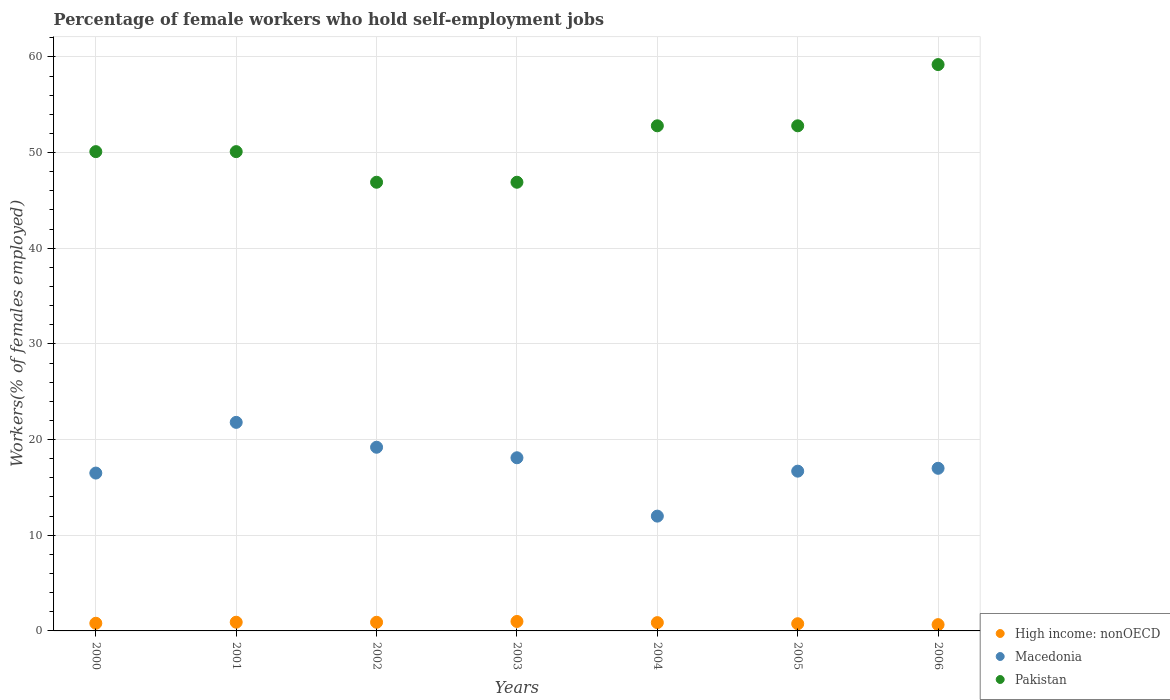How many different coloured dotlines are there?
Keep it short and to the point. 3. Is the number of dotlines equal to the number of legend labels?
Offer a very short reply. Yes. What is the percentage of self-employed female workers in High income: nonOECD in 2002?
Provide a succinct answer. 0.9. Across all years, what is the maximum percentage of self-employed female workers in Macedonia?
Your response must be concise. 21.8. Across all years, what is the minimum percentage of self-employed female workers in Pakistan?
Keep it short and to the point. 46.9. In which year was the percentage of self-employed female workers in Macedonia maximum?
Offer a very short reply. 2001. What is the total percentage of self-employed female workers in Macedonia in the graph?
Offer a terse response. 121.3. What is the difference between the percentage of self-employed female workers in Macedonia in 2005 and that in 2006?
Provide a succinct answer. -0.3. What is the difference between the percentage of self-employed female workers in Pakistan in 2003 and the percentage of self-employed female workers in Macedonia in 2001?
Your answer should be very brief. 25.1. What is the average percentage of self-employed female workers in High income: nonOECD per year?
Offer a very short reply. 0.84. In the year 2002, what is the difference between the percentage of self-employed female workers in Macedonia and percentage of self-employed female workers in Pakistan?
Give a very brief answer. -27.7. What is the ratio of the percentage of self-employed female workers in Pakistan in 2003 to that in 2006?
Provide a succinct answer. 0.79. Is the percentage of self-employed female workers in High income: nonOECD in 2001 less than that in 2003?
Provide a succinct answer. Yes. What is the difference between the highest and the second highest percentage of self-employed female workers in Pakistan?
Provide a short and direct response. 6.4. What is the difference between the highest and the lowest percentage of self-employed female workers in Pakistan?
Provide a short and direct response. 12.3. Does the percentage of self-employed female workers in Pakistan monotonically increase over the years?
Offer a very short reply. No. Is the percentage of self-employed female workers in Macedonia strictly less than the percentage of self-employed female workers in High income: nonOECD over the years?
Offer a terse response. No. How many legend labels are there?
Offer a terse response. 3. What is the title of the graph?
Keep it short and to the point. Percentage of female workers who hold self-employment jobs. Does "Italy" appear as one of the legend labels in the graph?
Provide a succinct answer. No. What is the label or title of the X-axis?
Offer a very short reply. Years. What is the label or title of the Y-axis?
Provide a succinct answer. Workers(% of females employed). What is the Workers(% of females employed) of High income: nonOECD in 2000?
Make the answer very short. 0.8. What is the Workers(% of females employed) in Pakistan in 2000?
Provide a succinct answer. 50.1. What is the Workers(% of females employed) in High income: nonOECD in 2001?
Give a very brief answer. 0.91. What is the Workers(% of females employed) in Macedonia in 2001?
Keep it short and to the point. 21.8. What is the Workers(% of females employed) of Pakistan in 2001?
Give a very brief answer. 50.1. What is the Workers(% of females employed) of High income: nonOECD in 2002?
Your answer should be compact. 0.9. What is the Workers(% of females employed) of Macedonia in 2002?
Your answer should be compact. 19.2. What is the Workers(% of females employed) of Pakistan in 2002?
Your answer should be very brief. 46.9. What is the Workers(% of females employed) of High income: nonOECD in 2003?
Your response must be concise. 0.99. What is the Workers(% of females employed) of Macedonia in 2003?
Your response must be concise. 18.1. What is the Workers(% of females employed) of Pakistan in 2003?
Provide a short and direct response. 46.9. What is the Workers(% of females employed) in High income: nonOECD in 2004?
Provide a succinct answer. 0.87. What is the Workers(% of females employed) of Pakistan in 2004?
Give a very brief answer. 52.8. What is the Workers(% of females employed) of High income: nonOECD in 2005?
Provide a succinct answer. 0.75. What is the Workers(% of females employed) in Macedonia in 2005?
Provide a succinct answer. 16.7. What is the Workers(% of females employed) of Pakistan in 2005?
Offer a very short reply. 52.8. What is the Workers(% of females employed) of High income: nonOECD in 2006?
Keep it short and to the point. 0.66. What is the Workers(% of females employed) in Macedonia in 2006?
Give a very brief answer. 17. What is the Workers(% of females employed) of Pakistan in 2006?
Keep it short and to the point. 59.2. Across all years, what is the maximum Workers(% of females employed) in High income: nonOECD?
Your response must be concise. 0.99. Across all years, what is the maximum Workers(% of females employed) in Macedonia?
Make the answer very short. 21.8. Across all years, what is the maximum Workers(% of females employed) of Pakistan?
Ensure brevity in your answer.  59.2. Across all years, what is the minimum Workers(% of females employed) in High income: nonOECD?
Provide a succinct answer. 0.66. Across all years, what is the minimum Workers(% of females employed) of Macedonia?
Offer a very short reply. 12. Across all years, what is the minimum Workers(% of females employed) of Pakistan?
Provide a short and direct response. 46.9. What is the total Workers(% of females employed) in High income: nonOECD in the graph?
Provide a succinct answer. 5.88. What is the total Workers(% of females employed) of Macedonia in the graph?
Your answer should be compact. 121.3. What is the total Workers(% of females employed) in Pakistan in the graph?
Keep it short and to the point. 358.8. What is the difference between the Workers(% of females employed) in High income: nonOECD in 2000 and that in 2001?
Your response must be concise. -0.11. What is the difference between the Workers(% of females employed) of Macedonia in 2000 and that in 2001?
Keep it short and to the point. -5.3. What is the difference between the Workers(% of females employed) of High income: nonOECD in 2000 and that in 2002?
Make the answer very short. -0.1. What is the difference between the Workers(% of females employed) in Pakistan in 2000 and that in 2002?
Your response must be concise. 3.2. What is the difference between the Workers(% of females employed) of High income: nonOECD in 2000 and that in 2003?
Give a very brief answer. -0.19. What is the difference between the Workers(% of females employed) of High income: nonOECD in 2000 and that in 2004?
Your answer should be compact. -0.07. What is the difference between the Workers(% of females employed) in Pakistan in 2000 and that in 2004?
Your response must be concise. -2.7. What is the difference between the Workers(% of females employed) in High income: nonOECD in 2000 and that in 2005?
Ensure brevity in your answer.  0.05. What is the difference between the Workers(% of females employed) in Pakistan in 2000 and that in 2005?
Offer a terse response. -2.7. What is the difference between the Workers(% of females employed) in High income: nonOECD in 2000 and that in 2006?
Keep it short and to the point. 0.14. What is the difference between the Workers(% of females employed) in High income: nonOECD in 2001 and that in 2002?
Your response must be concise. 0.01. What is the difference between the Workers(% of females employed) in High income: nonOECD in 2001 and that in 2003?
Your answer should be very brief. -0.08. What is the difference between the Workers(% of females employed) in Pakistan in 2001 and that in 2003?
Give a very brief answer. 3.2. What is the difference between the Workers(% of females employed) in High income: nonOECD in 2001 and that in 2004?
Make the answer very short. 0.04. What is the difference between the Workers(% of females employed) of Macedonia in 2001 and that in 2004?
Ensure brevity in your answer.  9.8. What is the difference between the Workers(% of females employed) in Pakistan in 2001 and that in 2004?
Offer a terse response. -2.7. What is the difference between the Workers(% of females employed) in High income: nonOECD in 2001 and that in 2005?
Your answer should be very brief. 0.16. What is the difference between the Workers(% of females employed) of Macedonia in 2001 and that in 2005?
Make the answer very short. 5.1. What is the difference between the Workers(% of females employed) in High income: nonOECD in 2001 and that in 2006?
Your response must be concise. 0.25. What is the difference between the Workers(% of females employed) of Macedonia in 2001 and that in 2006?
Your response must be concise. 4.8. What is the difference between the Workers(% of females employed) in Pakistan in 2001 and that in 2006?
Keep it short and to the point. -9.1. What is the difference between the Workers(% of females employed) of High income: nonOECD in 2002 and that in 2003?
Make the answer very short. -0.08. What is the difference between the Workers(% of females employed) of Macedonia in 2002 and that in 2003?
Keep it short and to the point. 1.1. What is the difference between the Workers(% of females employed) of Pakistan in 2002 and that in 2003?
Offer a terse response. 0. What is the difference between the Workers(% of females employed) in High income: nonOECD in 2002 and that in 2004?
Offer a very short reply. 0.04. What is the difference between the Workers(% of females employed) of Pakistan in 2002 and that in 2004?
Provide a short and direct response. -5.9. What is the difference between the Workers(% of females employed) of High income: nonOECD in 2002 and that in 2005?
Your answer should be very brief. 0.15. What is the difference between the Workers(% of females employed) of Pakistan in 2002 and that in 2005?
Your answer should be compact. -5.9. What is the difference between the Workers(% of females employed) in High income: nonOECD in 2002 and that in 2006?
Your answer should be very brief. 0.25. What is the difference between the Workers(% of females employed) of Pakistan in 2002 and that in 2006?
Give a very brief answer. -12.3. What is the difference between the Workers(% of females employed) of High income: nonOECD in 2003 and that in 2004?
Ensure brevity in your answer.  0.12. What is the difference between the Workers(% of females employed) of Pakistan in 2003 and that in 2004?
Keep it short and to the point. -5.9. What is the difference between the Workers(% of females employed) of High income: nonOECD in 2003 and that in 2005?
Your response must be concise. 0.24. What is the difference between the Workers(% of females employed) of Pakistan in 2003 and that in 2005?
Make the answer very short. -5.9. What is the difference between the Workers(% of females employed) in High income: nonOECD in 2003 and that in 2006?
Make the answer very short. 0.33. What is the difference between the Workers(% of females employed) of Macedonia in 2003 and that in 2006?
Make the answer very short. 1.1. What is the difference between the Workers(% of females employed) of High income: nonOECD in 2004 and that in 2005?
Provide a succinct answer. 0.11. What is the difference between the Workers(% of females employed) of Macedonia in 2004 and that in 2005?
Your response must be concise. -4.7. What is the difference between the Workers(% of females employed) of Pakistan in 2004 and that in 2005?
Your answer should be very brief. 0. What is the difference between the Workers(% of females employed) of High income: nonOECD in 2004 and that in 2006?
Your answer should be compact. 0.21. What is the difference between the Workers(% of females employed) of Macedonia in 2004 and that in 2006?
Provide a short and direct response. -5. What is the difference between the Workers(% of females employed) of Pakistan in 2004 and that in 2006?
Your answer should be compact. -6.4. What is the difference between the Workers(% of females employed) of High income: nonOECD in 2005 and that in 2006?
Provide a short and direct response. 0.1. What is the difference between the Workers(% of females employed) in Macedonia in 2005 and that in 2006?
Provide a short and direct response. -0.3. What is the difference between the Workers(% of females employed) in Pakistan in 2005 and that in 2006?
Ensure brevity in your answer.  -6.4. What is the difference between the Workers(% of females employed) in High income: nonOECD in 2000 and the Workers(% of females employed) in Macedonia in 2001?
Your answer should be compact. -21. What is the difference between the Workers(% of females employed) of High income: nonOECD in 2000 and the Workers(% of females employed) of Pakistan in 2001?
Give a very brief answer. -49.3. What is the difference between the Workers(% of females employed) of Macedonia in 2000 and the Workers(% of females employed) of Pakistan in 2001?
Your answer should be compact. -33.6. What is the difference between the Workers(% of females employed) in High income: nonOECD in 2000 and the Workers(% of females employed) in Macedonia in 2002?
Your answer should be very brief. -18.4. What is the difference between the Workers(% of females employed) of High income: nonOECD in 2000 and the Workers(% of females employed) of Pakistan in 2002?
Your answer should be compact. -46.1. What is the difference between the Workers(% of females employed) in Macedonia in 2000 and the Workers(% of females employed) in Pakistan in 2002?
Give a very brief answer. -30.4. What is the difference between the Workers(% of females employed) in High income: nonOECD in 2000 and the Workers(% of females employed) in Macedonia in 2003?
Provide a short and direct response. -17.3. What is the difference between the Workers(% of females employed) in High income: nonOECD in 2000 and the Workers(% of females employed) in Pakistan in 2003?
Your answer should be very brief. -46.1. What is the difference between the Workers(% of females employed) in Macedonia in 2000 and the Workers(% of females employed) in Pakistan in 2003?
Provide a short and direct response. -30.4. What is the difference between the Workers(% of females employed) of High income: nonOECD in 2000 and the Workers(% of females employed) of Macedonia in 2004?
Provide a succinct answer. -11.2. What is the difference between the Workers(% of females employed) in High income: nonOECD in 2000 and the Workers(% of females employed) in Pakistan in 2004?
Keep it short and to the point. -52. What is the difference between the Workers(% of females employed) of Macedonia in 2000 and the Workers(% of females employed) of Pakistan in 2004?
Ensure brevity in your answer.  -36.3. What is the difference between the Workers(% of females employed) of High income: nonOECD in 2000 and the Workers(% of females employed) of Macedonia in 2005?
Your response must be concise. -15.9. What is the difference between the Workers(% of females employed) in High income: nonOECD in 2000 and the Workers(% of females employed) in Pakistan in 2005?
Offer a terse response. -52. What is the difference between the Workers(% of females employed) of Macedonia in 2000 and the Workers(% of females employed) of Pakistan in 2005?
Keep it short and to the point. -36.3. What is the difference between the Workers(% of females employed) of High income: nonOECD in 2000 and the Workers(% of females employed) of Macedonia in 2006?
Your answer should be compact. -16.2. What is the difference between the Workers(% of females employed) of High income: nonOECD in 2000 and the Workers(% of females employed) of Pakistan in 2006?
Ensure brevity in your answer.  -58.4. What is the difference between the Workers(% of females employed) of Macedonia in 2000 and the Workers(% of females employed) of Pakistan in 2006?
Your answer should be compact. -42.7. What is the difference between the Workers(% of females employed) in High income: nonOECD in 2001 and the Workers(% of females employed) in Macedonia in 2002?
Provide a succinct answer. -18.29. What is the difference between the Workers(% of females employed) of High income: nonOECD in 2001 and the Workers(% of females employed) of Pakistan in 2002?
Offer a terse response. -45.99. What is the difference between the Workers(% of females employed) of Macedonia in 2001 and the Workers(% of females employed) of Pakistan in 2002?
Provide a succinct answer. -25.1. What is the difference between the Workers(% of females employed) in High income: nonOECD in 2001 and the Workers(% of females employed) in Macedonia in 2003?
Offer a terse response. -17.19. What is the difference between the Workers(% of females employed) of High income: nonOECD in 2001 and the Workers(% of females employed) of Pakistan in 2003?
Offer a terse response. -45.99. What is the difference between the Workers(% of females employed) in Macedonia in 2001 and the Workers(% of females employed) in Pakistan in 2003?
Provide a short and direct response. -25.1. What is the difference between the Workers(% of females employed) in High income: nonOECD in 2001 and the Workers(% of females employed) in Macedonia in 2004?
Your response must be concise. -11.09. What is the difference between the Workers(% of females employed) of High income: nonOECD in 2001 and the Workers(% of females employed) of Pakistan in 2004?
Offer a terse response. -51.89. What is the difference between the Workers(% of females employed) of Macedonia in 2001 and the Workers(% of females employed) of Pakistan in 2004?
Your answer should be very brief. -31. What is the difference between the Workers(% of females employed) of High income: nonOECD in 2001 and the Workers(% of females employed) of Macedonia in 2005?
Offer a very short reply. -15.79. What is the difference between the Workers(% of females employed) in High income: nonOECD in 2001 and the Workers(% of females employed) in Pakistan in 2005?
Your answer should be compact. -51.89. What is the difference between the Workers(% of females employed) in Macedonia in 2001 and the Workers(% of females employed) in Pakistan in 2005?
Provide a short and direct response. -31. What is the difference between the Workers(% of females employed) in High income: nonOECD in 2001 and the Workers(% of females employed) in Macedonia in 2006?
Your answer should be compact. -16.09. What is the difference between the Workers(% of females employed) in High income: nonOECD in 2001 and the Workers(% of females employed) in Pakistan in 2006?
Offer a terse response. -58.29. What is the difference between the Workers(% of females employed) of Macedonia in 2001 and the Workers(% of females employed) of Pakistan in 2006?
Offer a terse response. -37.4. What is the difference between the Workers(% of females employed) in High income: nonOECD in 2002 and the Workers(% of females employed) in Macedonia in 2003?
Keep it short and to the point. -17.2. What is the difference between the Workers(% of females employed) of High income: nonOECD in 2002 and the Workers(% of females employed) of Pakistan in 2003?
Offer a very short reply. -46. What is the difference between the Workers(% of females employed) of Macedonia in 2002 and the Workers(% of females employed) of Pakistan in 2003?
Your answer should be very brief. -27.7. What is the difference between the Workers(% of females employed) of High income: nonOECD in 2002 and the Workers(% of females employed) of Macedonia in 2004?
Give a very brief answer. -11.1. What is the difference between the Workers(% of females employed) in High income: nonOECD in 2002 and the Workers(% of females employed) in Pakistan in 2004?
Provide a succinct answer. -51.9. What is the difference between the Workers(% of females employed) of Macedonia in 2002 and the Workers(% of females employed) of Pakistan in 2004?
Your answer should be very brief. -33.6. What is the difference between the Workers(% of females employed) of High income: nonOECD in 2002 and the Workers(% of females employed) of Macedonia in 2005?
Keep it short and to the point. -15.8. What is the difference between the Workers(% of females employed) in High income: nonOECD in 2002 and the Workers(% of females employed) in Pakistan in 2005?
Provide a succinct answer. -51.9. What is the difference between the Workers(% of females employed) of Macedonia in 2002 and the Workers(% of females employed) of Pakistan in 2005?
Provide a succinct answer. -33.6. What is the difference between the Workers(% of females employed) in High income: nonOECD in 2002 and the Workers(% of females employed) in Macedonia in 2006?
Your answer should be very brief. -16.1. What is the difference between the Workers(% of females employed) in High income: nonOECD in 2002 and the Workers(% of females employed) in Pakistan in 2006?
Make the answer very short. -58.3. What is the difference between the Workers(% of females employed) in Macedonia in 2002 and the Workers(% of females employed) in Pakistan in 2006?
Keep it short and to the point. -40. What is the difference between the Workers(% of females employed) of High income: nonOECD in 2003 and the Workers(% of females employed) of Macedonia in 2004?
Your response must be concise. -11.01. What is the difference between the Workers(% of females employed) of High income: nonOECD in 2003 and the Workers(% of females employed) of Pakistan in 2004?
Offer a terse response. -51.81. What is the difference between the Workers(% of females employed) in Macedonia in 2003 and the Workers(% of females employed) in Pakistan in 2004?
Offer a very short reply. -34.7. What is the difference between the Workers(% of females employed) of High income: nonOECD in 2003 and the Workers(% of females employed) of Macedonia in 2005?
Provide a succinct answer. -15.71. What is the difference between the Workers(% of females employed) in High income: nonOECD in 2003 and the Workers(% of females employed) in Pakistan in 2005?
Ensure brevity in your answer.  -51.81. What is the difference between the Workers(% of females employed) of Macedonia in 2003 and the Workers(% of females employed) of Pakistan in 2005?
Give a very brief answer. -34.7. What is the difference between the Workers(% of females employed) in High income: nonOECD in 2003 and the Workers(% of females employed) in Macedonia in 2006?
Your answer should be compact. -16.01. What is the difference between the Workers(% of females employed) of High income: nonOECD in 2003 and the Workers(% of females employed) of Pakistan in 2006?
Give a very brief answer. -58.21. What is the difference between the Workers(% of females employed) of Macedonia in 2003 and the Workers(% of females employed) of Pakistan in 2006?
Your answer should be compact. -41.1. What is the difference between the Workers(% of females employed) in High income: nonOECD in 2004 and the Workers(% of females employed) in Macedonia in 2005?
Offer a terse response. -15.83. What is the difference between the Workers(% of females employed) in High income: nonOECD in 2004 and the Workers(% of females employed) in Pakistan in 2005?
Your response must be concise. -51.93. What is the difference between the Workers(% of females employed) of Macedonia in 2004 and the Workers(% of females employed) of Pakistan in 2005?
Keep it short and to the point. -40.8. What is the difference between the Workers(% of females employed) in High income: nonOECD in 2004 and the Workers(% of females employed) in Macedonia in 2006?
Offer a very short reply. -16.13. What is the difference between the Workers(% of females employed) of High income: nonOECD in 2004 and the Workers(% of females employed) of Pakistan in 2006?
Keep it short and to the point. -58.33. What is the difference between the Workers(% of females employed) of Macedonia in 2004 and the Workers(% of females employed) of Pakistan in 2006?
Offer a terse response. -47.2. What is the difference between the Workers(% of females employed) in High income: nonOECD in 2005 and the Workers(% of females employed) in Macedonia in 2006?
Make the answer very short. -16.25. What is the difference between the Workers(% of females employed) of High income: nonOECD in 2005 and the Workers(% of females employed) of Pakistan in 2006?
Your response must be concise. -58.45. What is the difference between the Workers(% of females employed) of Macedonia in 2005 and the Workers(% of females employed) of Pakistan in 2006?
Offer a very short reply. -42.5. What is the average Workers(% of females employed) in High income: nonOECD per year?
Keep it short and to the point. 0.84. What is the average Workers(% of females employed) of Macedonia per year?
Offer a terse response. 17.33. What is the average Workers(% of females employed) of Pakistan per year?
Offer a very short reply. 51.26. In the year 2000, what is the difference between the Workers(% of females employed) in High income: nonOECD and Workers(% of females employed) in Macedonia?
Offer a terse response. -15.7. In the year 2000, what is the difference between the Workers(% of females employed) of High income: nonOECD and Workers(% of females employed) of Pakistan?
Offer a very short reply. -49.3. In the year 2000, what is the difference between the Workers(% of females employed) of Macedonia and Workers(% of females employed) of Pakistan?
Ensure brevity in your answer.  -33.6. In the year 2001, what is the difference between the Workers(% of females employed) of High income: nonOECD and Workers(% of females employed) of Macedonia?
Your response must be concise. -20.89. In the year 2001, what is the difference between the Workers(% of females employed) of High income: nonOECD and Workers(% of females employed) of Pakistan?
Ensure brevity in your answer.  -49.19. In the year 2001, what is the difference between the Workers(% of females employed) in Macedonia and Workers(% of females employed) in Pakistan?
Provide a short and direct response. -28.3. In the year 2002, what is the difference between the Workers(% of females employed) in High income: nonOECD and Workers(% of females employed) in Macedonia?
Ensure brevity in your answer.  -18.3. In the year 2002, what is the difference between the Workers(% of females employed) in High income: nonOECD and Workers(% of females employed) in Pakistan?
Offer a terse response. -46. In the year 2002, what is the difference between the Workers(% of females employed) in Macedonia and Workers(% of females employed) in Pakistan?
Your answer should be compact. -27.7. In the year 2003, what is the difference between the Workers(% of females employed) of High income: nonOECD and Workers(% of females employed) of Macedonia?
Offer a terse response. -17.11. In the year 2003, what is the difference between the Workers(% of females employed) in High income: nonOECD and Workers(% of females employed) in Pakistan?
Make the answer very short. -45.91. In the year 2003, what is the difference between the Workers(% of females employed) of Macedonia and Workers(% of females employed) of Pakistan?
Offer a terse response. -28.8. In the year 2004, what is the difference between the Workers(% of females employed) in High income: nonOECD and Workers(% of females employed) in Macedonia?
Provide a short and direct response. -11.13. In the year 2004, what is the difference between the Workers(% of females employed) in High income: nonOECD and Workers(% of females employed) in Pakistan?
Ensure brevity in your answer.  -51.93. In the year 2004, what is the difference between the Workers(% of females employed) in Macedonia and Workers(% of females employed) in Pakistan?
Your response must be concise. -40.8. In the year 2005, what is the difference between the Workers(% of females employed) of High income: nonOECD and Workers(% of females employed) of Macedonia?
Keep it short and to the point. -15.95. In the year 2005, what is the difference between the Workers(% of females employed) of High income: nonOECD and Workers(% of females employed) of Pakistan?
Offer a terse response. -52.05. In the year 2005, what is the difference between the Workers(% of females employed) in Macedonia and Workers(% of females employed) in Pakistan?
Provide a succinct answer. -36.1. In the year 2006, what is the difference between the Workers(% of females employed) of High income: nonOECD and Workers(% of females employed) of Macedonia?
Make the answer very short. -16.34. In the year 2006, what is the difference between the Workers(% of females employed) of High income: nonOECD and Workers(% of females employed) of Pakistan?
Ensure brevity in your answer.  -58.54. In the year 2006, what is the difference between the Workers(% of females employed) in Macedonia and Workers(% of females employed) in Pakistan?
Keep it short and to the point. -42.2. What is the ratio of the Workers(% of females employed) in High income: nonOECD in 2000 to that in 2001?
Provide a succinct answer. 0.88. What is the ratio of the Workers(% of females employed) in Macedonia in 2000 to that in 2001?
Your response must be concise. 0.76. What is the ratio of the Workers(% of females employed) in High income: nonOECD in 2000 to that in 2002?
Your answer should be compact. 0.89. What is the ratio of the Workers(% of females employed) in Macedonia in 2000 to that in 2002?
Keep it short and to the point. 0.86. What is the ratio of the Workers(% of females employed) of Pakistan in 2000 to that in 2002?
Keep it short and to the point. 1.07. What is the ratio of the Workers(% of females employed) in High income: nonOECD in 2000 to that in 2003?
Offer a very short reply. 0.81. What is the ratio of the Workers(% of females employed) in Macedonia in 2000 to that in 2003?
Offer a very short reply. 0.91. What is the ratio of the Workers(% of females employed) in Pakistan in 2000 to that in 2003?
Provide a succinct answer. 1.07. What is the ratio of the Workers(% of females employed) of High income: nonOECD in 2000 to that in 2004?
Your response must be concise. 0.92. What is the ratio of the Workers(% of females employed) in Macedonia in 2000 to that in 2004?
Offer a very short reply. 1.38. What is the ratio of the Workers(% of females employed) in Pakistan in 2000 to that in 2004?
Offer a very short reply. 0.95. What is the ratio of the Workers(% of females employed) of High income: nonOECD in 2000 to that in 2005?
Provide a short and direct response. 1.06. What is the ratio of the Workers(% of females employed) in Macedonia in 2000 to that in 2005?
Offer a terse response. 0.99. What is the ratio of the Workers(% of females employed) in Pakistan in 2000 to that in 2005?
Your response must be concise. 0.95. What is the ratio of the Workers(% of females employed) in High income: nonOECD in 2000 to that in 2006?
Ensure brevity in your answer.  1.22. What is the ratio of the Workers(% of females employed) of Macedonia in 2000 to that in 2006?
Offer a very short reply. 0.97. What is the ratio of the Workers(% of females employed) of Pakistan in 2000 to that in 2006?
Offer a very short reply. 0.85. What is the ratio of the Workers(% of females employed) of High income: nonOECD in 2001 to that in 2002?
Ensure brevity in your answer.  1.01. What is the ratio of the Workers(% of females employed) of Macedonia in 2001 to that in 2002?
Give a very brief answer. 1.14. What is the ratio of the Workers(% of females employed) of Pakistan in 2001 to that in 2002?
Your answer should be compact. 1.07. What is the ratio of the Workers(% of females employed) in High income: nonOECD in 2001 to that in 2003?
Give a very brief answer. 0.92. What is the ratio of the Workers(% of females employed) in Macedonia in 2001 to that in 2003?
Ensure brevity in your answer.  1.2. What is the ratio of the Workers(% of females employed) of Pakistan in 2001 to that in 2003?
Your answer should be very brief. 1.07. What is the ratio of the Workers(% of females employed) in High income: nonOECD in 2001 to that in 2004?
Your answer should be very brief. 1.05. What is the ratio of the Workers(% of females employed) of Macedonia in 2001 to that in 2004?
Your answer should be very brief. 1.82. What is the ratio of the Workers(% of females employed) in Pakistan in 2001 to that in 2004?
Keep it short and to the point. 0.95. What is the ratio of the Workers(% of females employed) of High income: nonOECD in 2001 to that in 2005?
Keep it short and to the point. 1.21. What is the ratio of the Workers(% of females employed) in Macedonia in 2001 to that in 2005?
Your answer should be very brief. 1.31. What is the ratio of the Workers(% of females employed) of Pakistan in 2001 to that in 2005?
Ensure brevity in your answer.  0.95. What is the ratio of the Workers(% of females employed) of High income: nonOECD in 2001 to that in 2006?
Offer a terse response. 1.38. What is the ratio of the Workers(% of females employed) of Macedonia in 2001 to that in 2006?
Make the answer very short. 1.28. What is the ratio of the Workers(% of females employed) in Pakistan in 2001 to that in 2006?
Keep it short and to the point. 0.85. What is the ratio of the Workers(% of females employed) in High income: nonOECD in 2002 to that in 2003?
Keep it short and to the point. 0.91. What is the ratio of the Workers(% of females employed) of Macedonia in 2002 to that in 2003?
Give a very brief answer. 1.06. What is the ratio of the Workers(% of females employed) in High income: nonOECD in 2002 to that in 2004?
Make the answer very short. 1.04. What is the ratio of the Workers(% of females employed) in Macedonia in 2002 to that in 2004?
Give a very brief answer. 1.6. What is the ratio of the Workers(% of females employed) in Pakistan in 2002 to that in 2004?
Your answer should be compact. 0.89. What is the ratio of the Workers(% of females employed) of High income: nonOECD in 2002 to that in 2005?
Provide a short and direct response. 1.2. What is the ratio of the Workers(% of females employed) of Macedonia in 2002 to that in 2005?
Offer a very short reply. 1.15. What is the ratio of the Workers(% of females employed) in Pakistan in 2002 to that in 2005?
Your response must be concise. 0.89. What is the ratio of the Workers(% of females employed) in High income: nonOECD in 2002 to that in 2006?
Ensure brevity in your answer.  1.38. What is the ratio of the Workers(% of females employed) in Macedonia in 2002 to that in 2006?
Your answer should be compact. 1.13. What is the ratio of the Workers(% of females employed) in Pakistan in 2002 to that in 2006?
Your answer should be very brief. 0.79. What is the ratio of the Workers(% of females employed) of High income: nonOECD in 2003 to that in 2004?
Offer a terse response. 1.14. What is the ratio of the Workers(% of females employed) of Macedonia in 2003 to that in 2004?
Ensure brevity in your answer.  1.51. What is the ratio of the Workers(% of females employed) of Pakistan in 2003 to that in 2004?
Your response must be concise. 0.89. What is the ratio of the Workers(% of females employed) of High income: nonOECD in 2003 to that in 2005?
Make the answer very short. 1.31. What is the ratio of the Workers(% of females employed) of Macedonia in 2003 to that in 2005?
Your response must be concise. 1.08. What is the ratio of the Workers(% of females employed) of Pakistan in 2003 to that in 2005?
Provide a succinct answer. 0.89. What is the ratio of the Workers(% of females employed) of High income: nonOECD in 2003 to that in 2006?
Provide a short and direct response. 1.5. What is the ratio of the Workers(% of females employed) of Macedonia in 2003 to that in 2006?
Your answer should be compact. 1.06. What is the ratio of the Workers(% of females employed) of Pakistan in 2003 to that in 2006?
Give a very brief answer. 0.79. What is the ratio of the Workers(% of females employed) in High income: nonOECD in 2004 to that in 2005?
Ensure brevity in your answer.  1.15. What is the ratio of the Workers(% of females employed) of Macedonia in 2004 to that in 2005?
Offer a very short reply. 0.72. What is the ratio of the Workers(% of females employed) of Pakistan in 2004 to that in 2005?
Your answer should be very brief. 1. What is the ratio of the Workers(% of females employed) in High income: nonOECD in 2004 to that in 2006?
Ensure brevity in your answer.  1.32. What is the ratio of the Workers(% of females employed) of Macedonia in 2004 to that in 2006?
Ensure brevity in your answer.  0.71. What is the ratio of the Workers(% of females employed) in Pakistan in 2004 to that in 2006?
Provide a succinct answer. 0.89. What is the ratio of the Workers(% of females employed) of High income: nonOECD in 2005 to that in 2006?
Ensure brevity in your answer.  1.15. What is the ratio of the Workers(% of females employed) of Macedonia in 2005 to that in 2006?
Offer a terse response. 0.98. What is the ratio of the Workers(% of females employed) of Pakistan in 2005 to that in 2006?
Provide a short and direct response. 0.89. What is the difference between the highest and the second highest Workers(% of females employed) in High income: nonOECD?
Give a very brief answer. 0.08. What is the difference between the highest and the second highest Workers(% of females employed) in Macedonia?
Make the answer very short. 2.6. What is the difference between the highest and the second highest Workers(% of females employed) of Pakistan?
Provide a short and direct response. 6.4. What is the difference between the highest and the lowest Workers(% of females employed) of High income: nonOECD?
Ensure brevity in your answer.  0.33. 